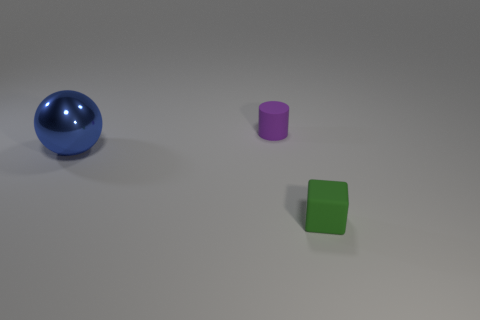There is a object that is both behind the matte block and on the right side of the large blue sphere; what is its color?
Give a very brief answer. Purple. How big is the metal sphere?
Offer a terse response. Large. How many other cubes have the same size as the green cube?
Ensure brevity in your answer.  0. Are the small object that is behind the matte cube and the sphere that is behind the green object made of the same material?
Offer a terse response. No. There is a tiny object left of the tiny matte object on the right side of the purple matte thing; what is its material?
Your answer should be very brief. Rubber. What is the material of the tiny object that is behind the big ball?
Ensure brevity in your answer.  Rubber. What material is the small object behind the matte object that is on the right side of the small thing that is behind the metallic object?
Your answer should be very brief. Rubber. Are there any rubber objects in front of the small purple rubber object?
Give a very brief answer. Yes. There is another matte thing that is the same size as the purple thing; what shape is it?
Give a very brief answer. Cube. Is the cylinder made of the same material as the green object?
Your answer should be very brief. Yes. 